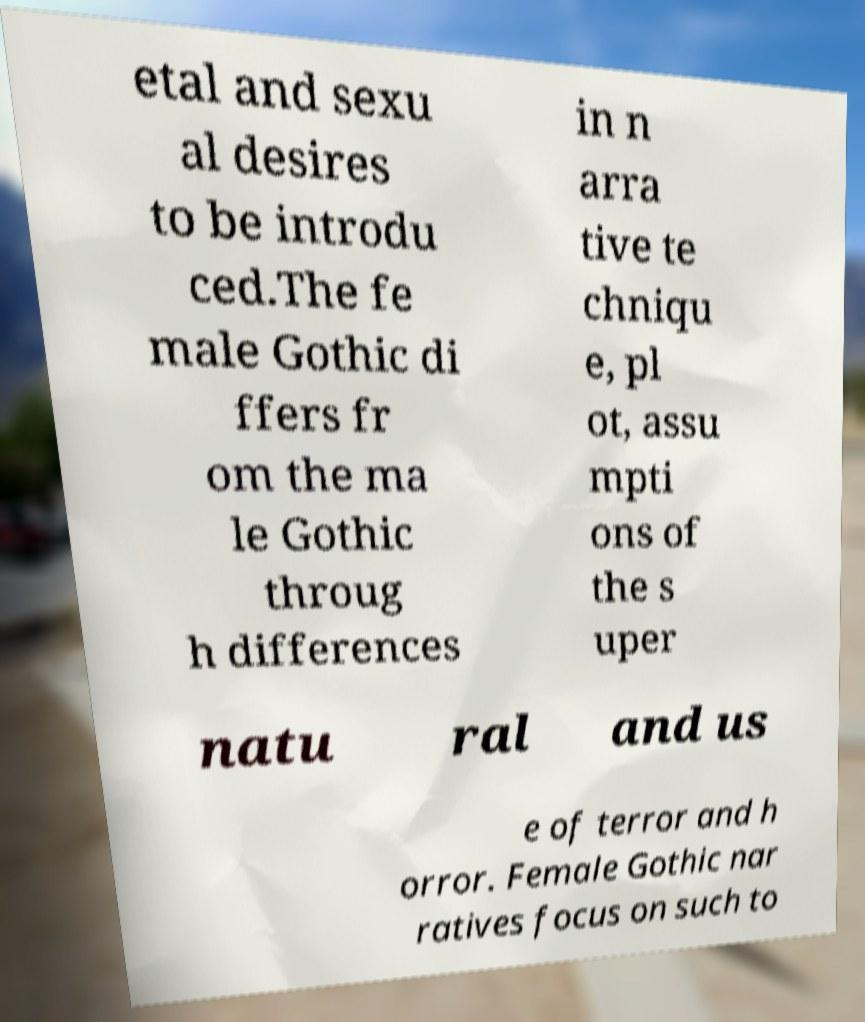Can you read and provide the text displayed in the image?This photo seems to have some interesting text. Can you extract and type it out for me? etal and sexu al desires to be introdu ced.The fe male Gothic di ffers fr om the ma le Gothic throug h differences in n arra tive te chniqu e, pl ot, assu mpti ons of the s uper natu ral and us e of terror and h orror. Female Gothic nar ratives focus on such to 